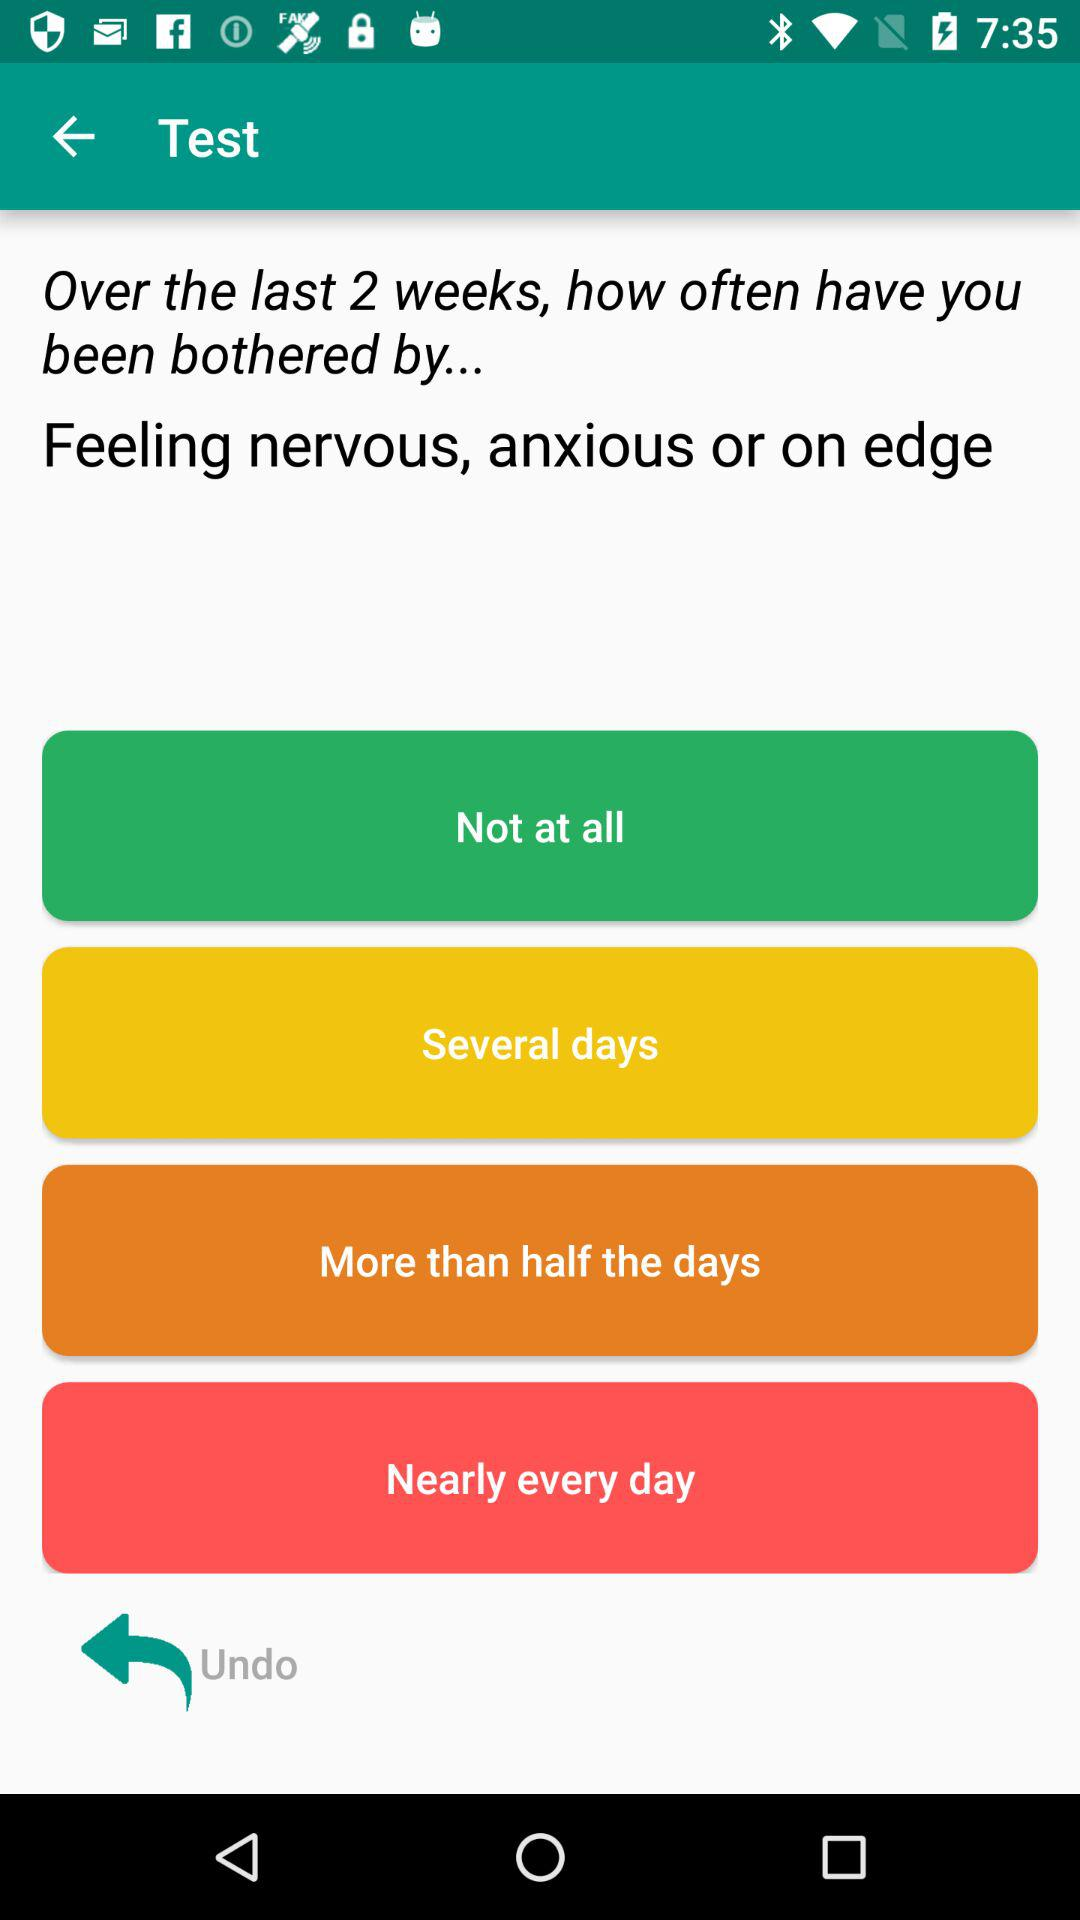How many options are there for how often you feel nervous, anxious or on edge?
Answer the question using a single word or phrase. 4 